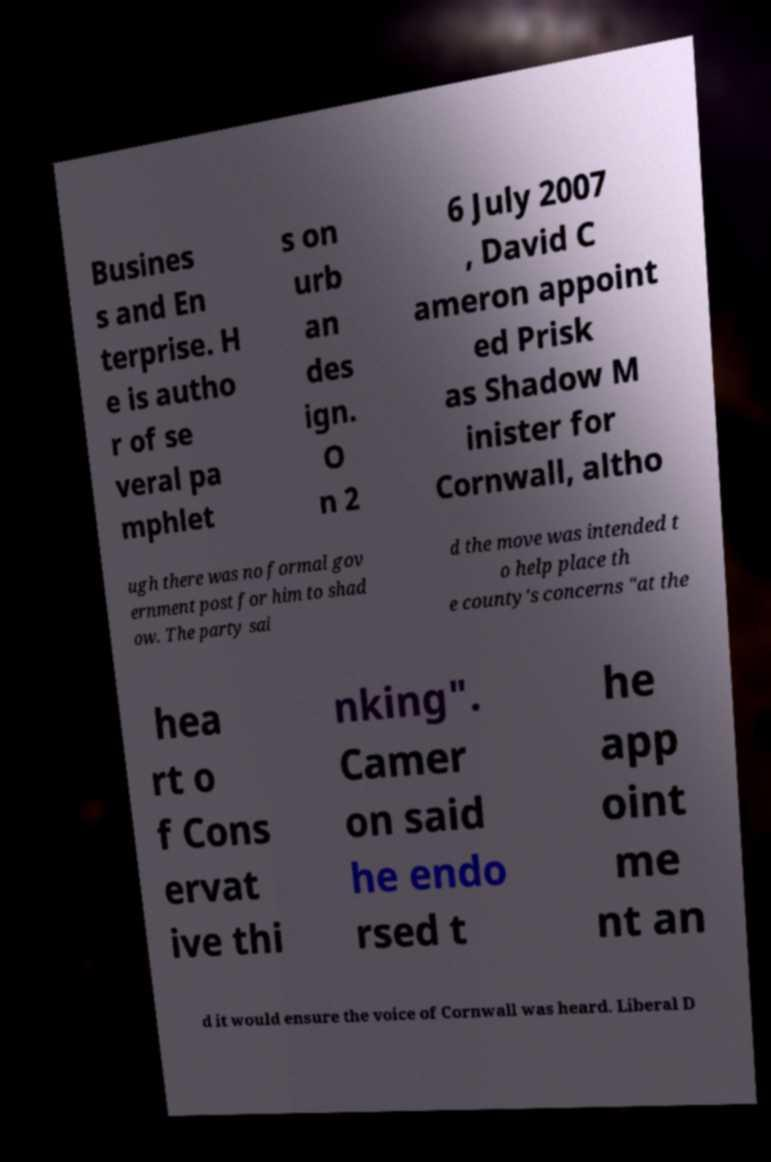There's text embedded in this image that I need extracted. Can you transcribe it verbatim? Busines s and En terprise. H e is autho r of se veral pa mphlet s on urb an des ign. O n 2 6 July 2007 , David C ameron appoint ed Prisk as Shadow M inister for Cornwall, altho ugh there was no formal gov ernment post for him to shad ow. The party sai d the move was intended t o help place th e county's concerns "at the hea rt o f Cons ervat ive thi nking". Camer on said he endo rsed t he app oint me nt an d it would ensure the voice of Cornwall was heard. Liberal D 